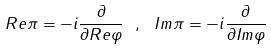<formula> <loc_0><loc_0><loc_500><loc_500>R e \pi = - i \frac { \partial } { \partial R e \varphi } \ , \ I m \pi = - i \frac { \partial } { \partial I m \varphi }</formula> 